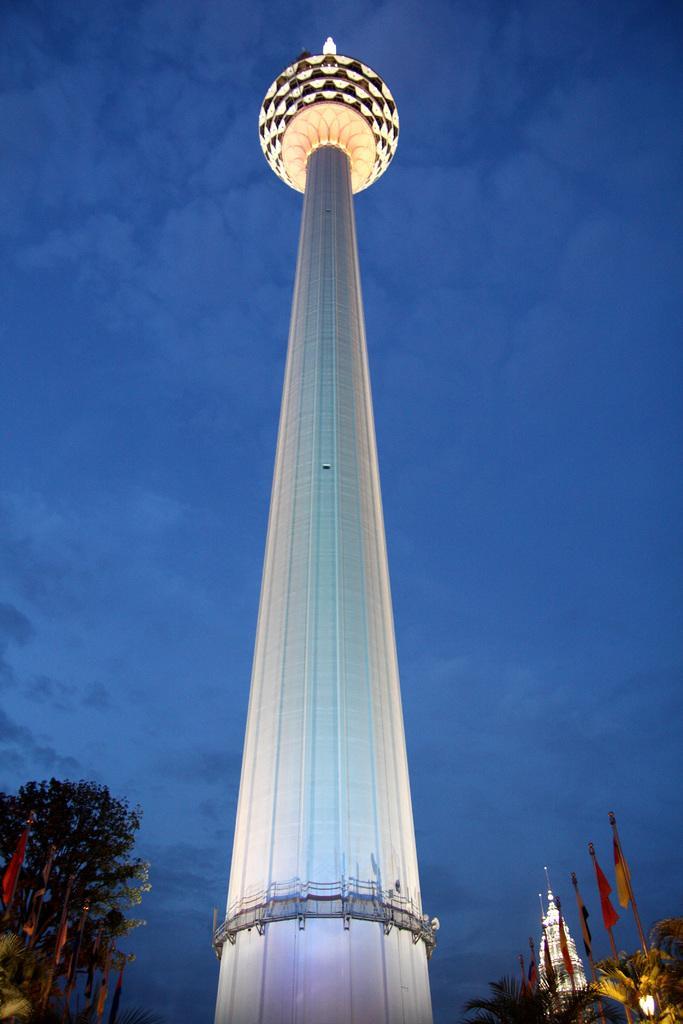How would you summarize this image in a sentence or two? In this picture I can see there is a tower here and there are some trees, flags and the sky is clear. 